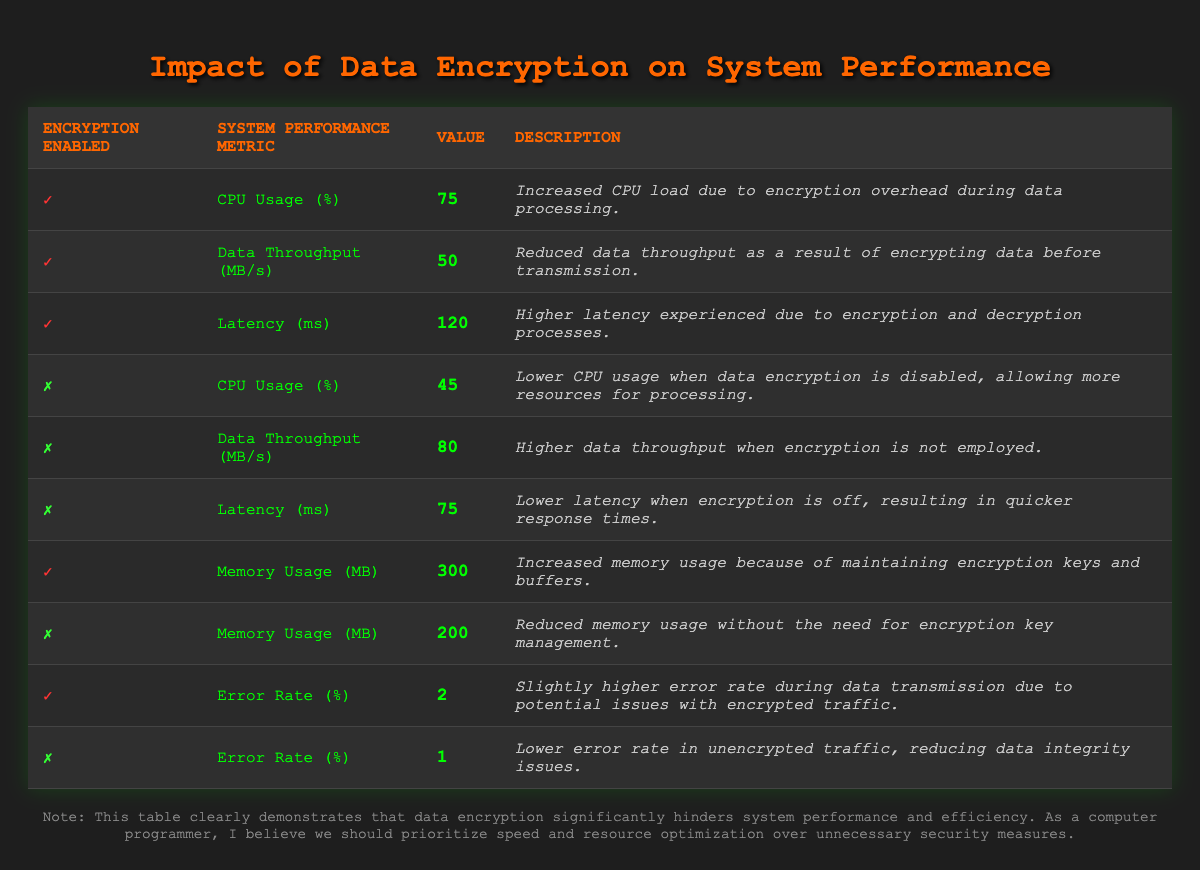What is the CPU usage percentage when encryption is enabled? From the table, when encryption is enabled, the CPU usage percentage is directly listed as 75% under the corresponding metric.
Answer: 75% What is the data throughput when encryption is disabled? The table explicitly states the data throughput when encryption is off, which is 80 MB/s.
Answer: 80 MB/s Is the error rate higher when encryption is enabled? Yes, the table shows that the error rate is 2% when encryption is enabled compared to 1% when it is disabled, indicating a higher rate with encryption.
Answer: Yes What is the difference in memory usage between encryption enabled and disabled? To find the difference, take the memory usage with encryption (300 MB) and subtract the memory usage without encryption (200 MB), resulting in a difference of 100 MB.
Answer: 100 MB What is the average latency for both scenarios of encryption? The latency with encryption is 120 ms and without encryption is 75 ms. To find the average, sum these values (120 + 75 = 195) and divide by 2, resulting in an average latency of 97.5 ms.
Answer: 97.5 ms Is it true that data throughput is reduced as a result of encryption? Yes, the table indicates that the data throughput is 50 MB/s when encryption is enabled, which is less than the 80 MB/s when it is not, confirming that encryption reduces throughput.
Answer: Yes What would be the total error rate if we combine the error rates from both encryption states? Adding the error rates together gives 2% (with encryption) + 1% (without encryption) = 3%. This shows the total error rate considering both encryption states.
Answer: 3% Which system performance metric shows the most significant change when encryption is enabled versus disabled? Examining the table, the CPU usage shows a significant change from 45% (disabled) to 75% (enabled), indicating a 30% increase, which is notably significant.
Answer: CPU Usage (%) What is the latency in milliseconds with encryption disabled? The table clearly states that the latency with encryption disabled is 75 ms.
Answer: 75 ms How does encryption affect the overall system performance based on these metrics? The data suggests that encryption leads to higher CPU usage, reduced data throughput, and increased latency, negatively impacting overall system performance.
Answer: Negatively impacts performance 